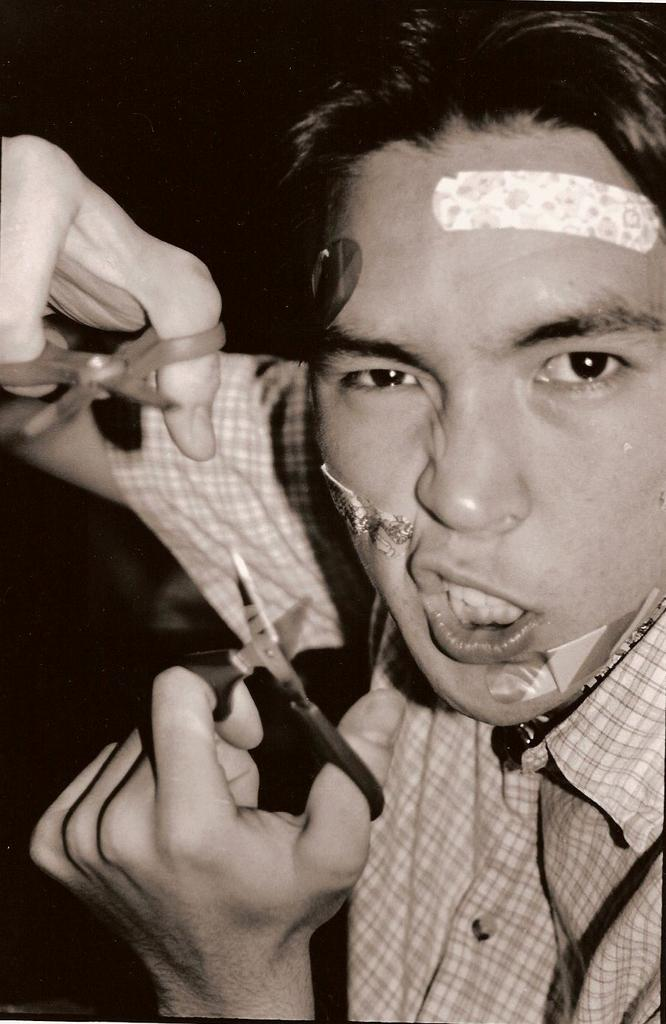Who is present in the image? There is a man in the image. What is the man holding in the image? The man is holding scissors. What can be observed about the background of the image? The background of the image is dark. What type of chalk is the man using to draw on the wall in the image? There is no chalk or wall present in the image; the man is holding scissors. What color is the underwear the man is wearing in the image? There is no information about the man's underwear in the image, as the focus is on the man holding scissors. 